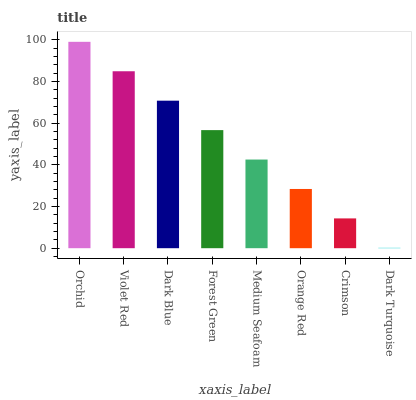Is Violet Red the minimum?
Answer yes or no. No. Is Violet Red the maximum?
Answer yes or no. No. Is Orchid greater than Violet Red?
Answer yes or no. Yes. Is Violet Red less than Orchid?
Answer yes or no. Yes. Is Violet Red greater than Orchid?
Answer yes or no. No. Is Orchid less than Violet Red?
Answer yes or no. No. Is Forest Green the high median?
Answer yes or no. Yes. Is Medium Seafoam the low median?
Answer yes or no. Yes. Is Violet Red the high median?
Answer yes or no. No. Is Forest Green the low median?
Answer yes or no. No. 